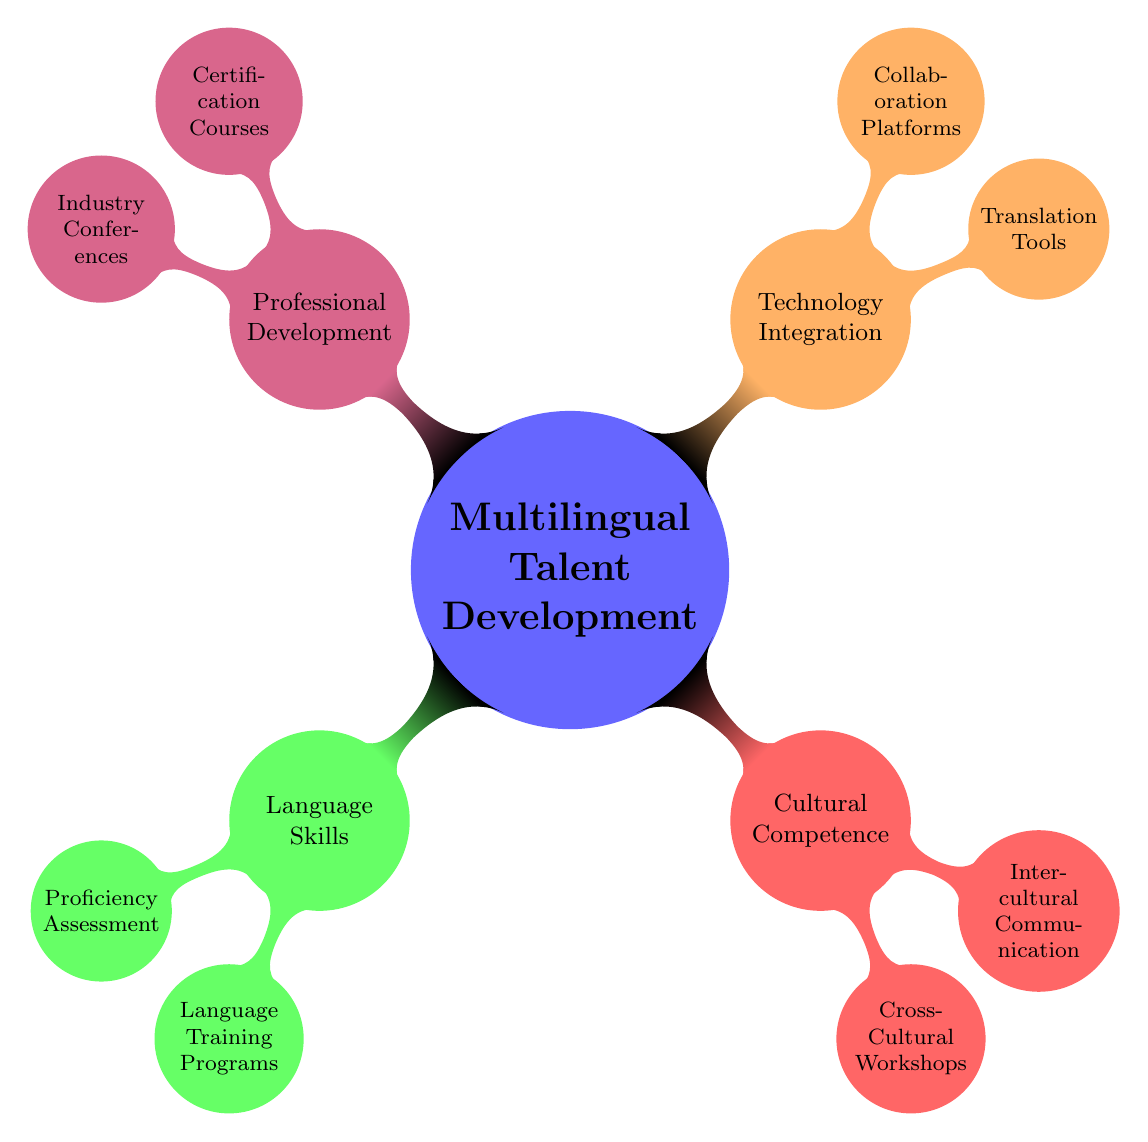What's the main topic of the mind map? The central node of the mind map represents the main topic, "Multilingual Talent Development."
Answer: Multilingual Talent Development How many main branches are there in the diagram? The main branches, or child nodes, coming from the main topic include Language Skills, Cultural Competence, Technology Integration, and Professional Development, totaling four branches.
Answer: 4 What are the two components under Language Skills? The child nodes under Language Skills are Proficiency Assessment and Language Training Programs.
Answer: Proficiency Assessment, Language Training Programs Which section includes certification courses? The component that contains certification courses is Professional Development.
Answer: Professional Development Which translation tools are listed under Technology Integration? The translation tools presented are DeepL, Google Translate, and SDL Trados.
Answer: DeepL, Google Translate, SDL Trados What is the relationship between Cross-Cultural Workshops and Cultural Competence? Cross-Cultural Workshops is a child node under the Cultural Competence branch, indicating it is a component of that category.
Answer: Child node of Cultural Competence How many nodes are there under Cultural Competence? There are two nodes under Cultural Competence, which are Cross-Cultural Workshops and Intercultural Communication.
Answer: 2 What type of programs are included under Language Training Programs? The programs listed here encompass various language training options like Rosetta Stone, DuoLingo, and Babbel.
Answer: Rosetta Stone, DuoLingo, Babbel Which collaboration platforms are mentioned in the Technology Integration section? The collaboration platforms included are Slack, Microsoft Teams, and Asana, which facilitate teamwork.
Answer: Slack, Microsoft Teams, Asana 